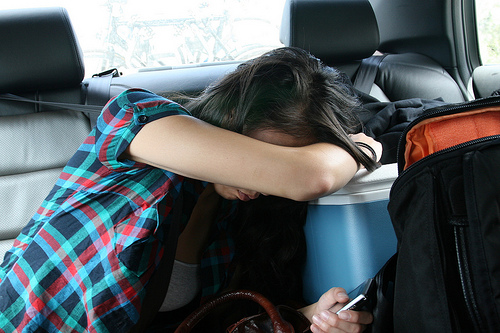<image>
Can you confirm if the women is in front of the car? No. The women is not in front of the car. The spatial positioning shows a different relationship between these objects. 